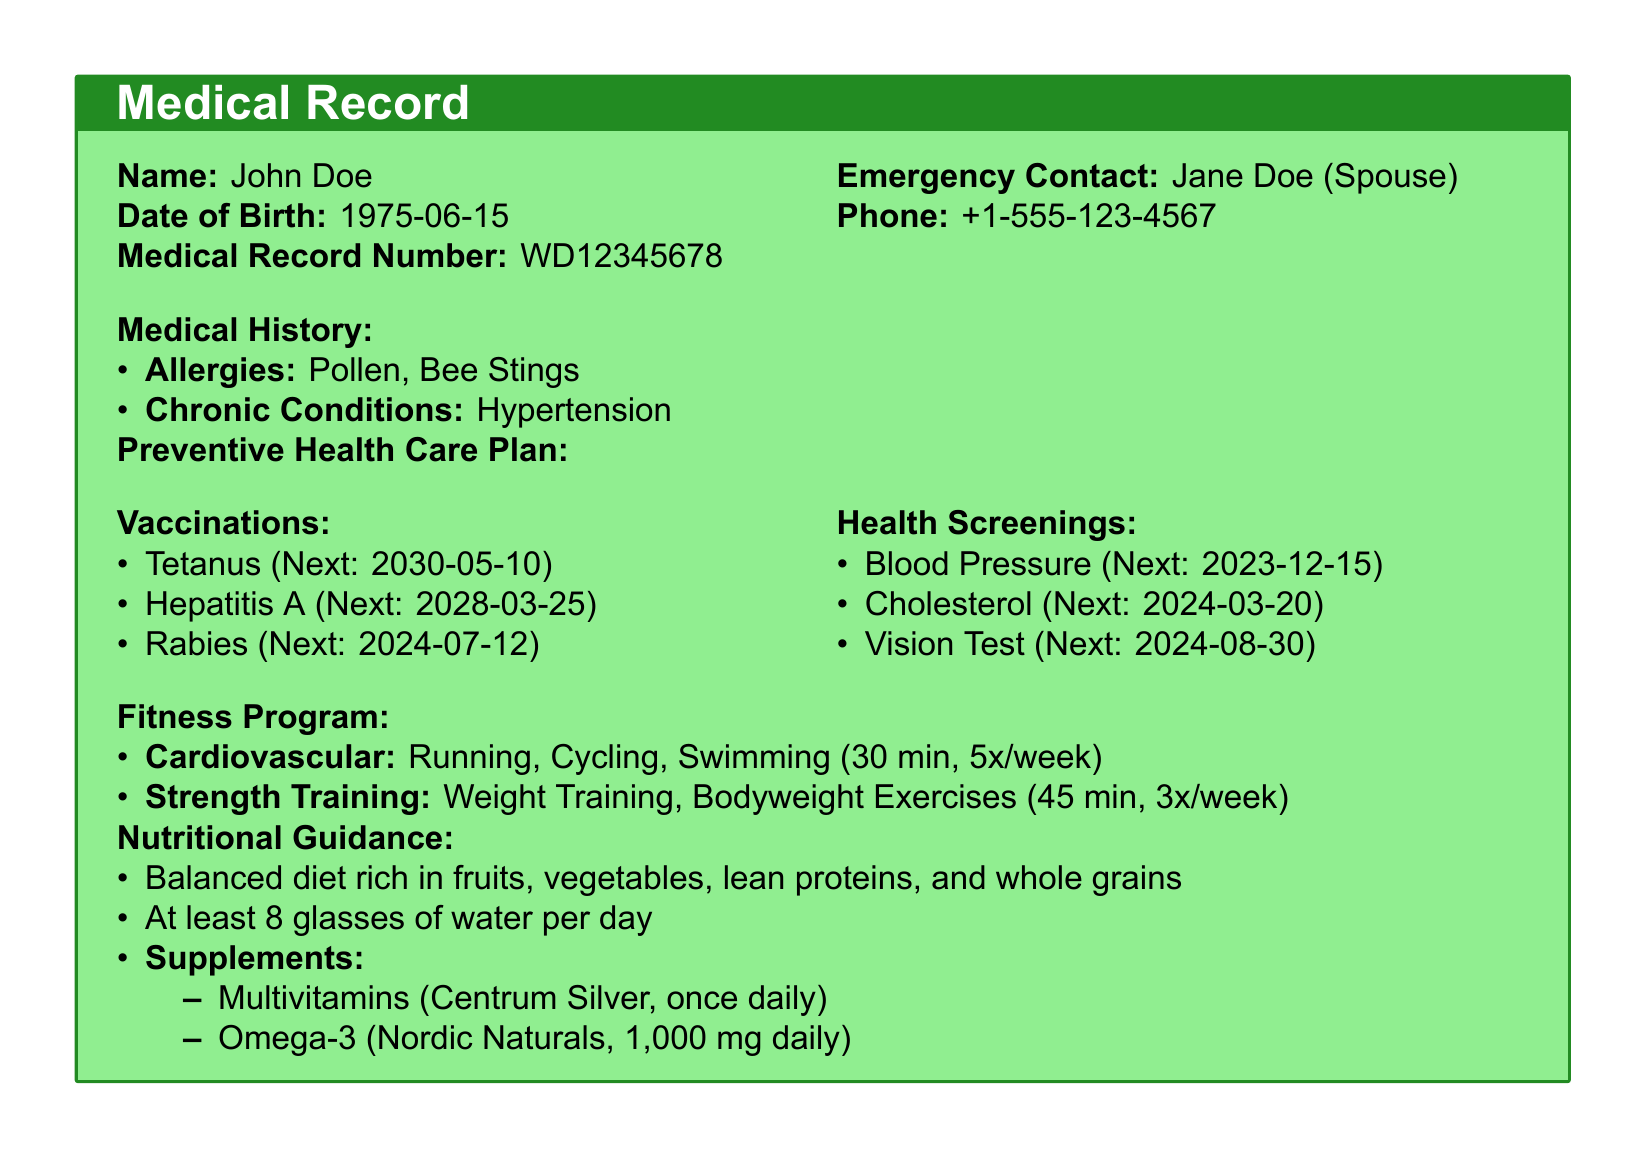What is the name of the individual in the medical record? The name of the individual is stated at the beginning of the document.
Answer: John Doe What is the date of birth of the individual? The date of birth can be found in the header section of the document.
Answer: 1975-06-15 What is the next scheduled date for Cholesterol screening? The screening dates are listed under health screenings in the document.
Answer: 2024-03-20 How many times a week is cardiovascular exercise scheduled? The fitness program section specifies the frequency of the exercises.
Answer: 5x/week What type of multivitamin is recommended in the nutritional guidance? The nutritional guidance includes details about specific supplements.
Answer: Centrum Silver What chronic condition is listed in the medical history? The chronic conditions are outlined under the medical history section.
Answer: Hypertension When is the next Rabies vaccination due? The vaccination schedule provides specific dates for upcoming vaccinations.
Answer: 2024-07-12 What is the individual's emergency contact's name? The emergency contact information is located at the top of the document.
Answer: Jane Doe What is the recommended daily water intake? The nutritional guidance specifies recommendations for hydration.
Answer: 8 glasses 